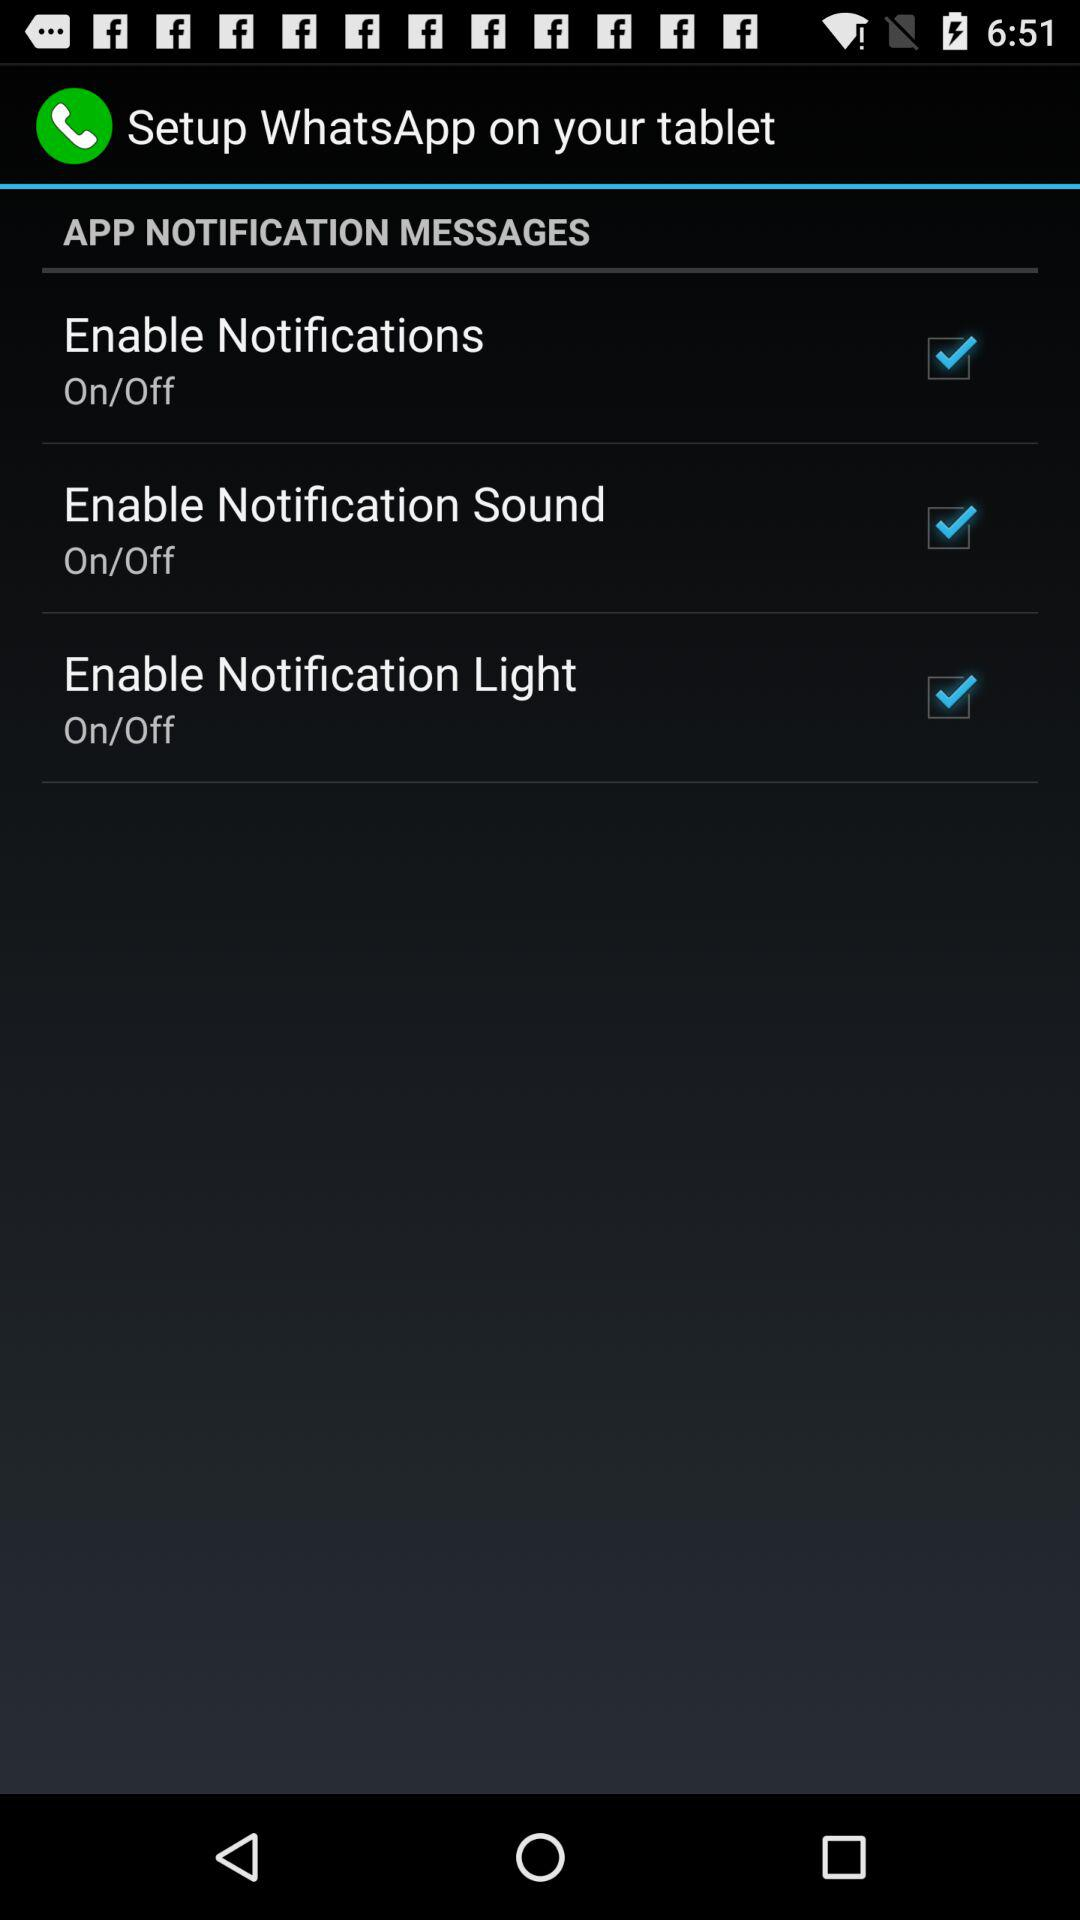How many checkboxes are in the notification settings?
Answer the question using a single word or phrase. 3 